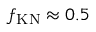Convert formula to latex. <formula><loc_0><loc_0><loc_500><loc_500>f _ { K N } \approx 0 . 5</formula> 